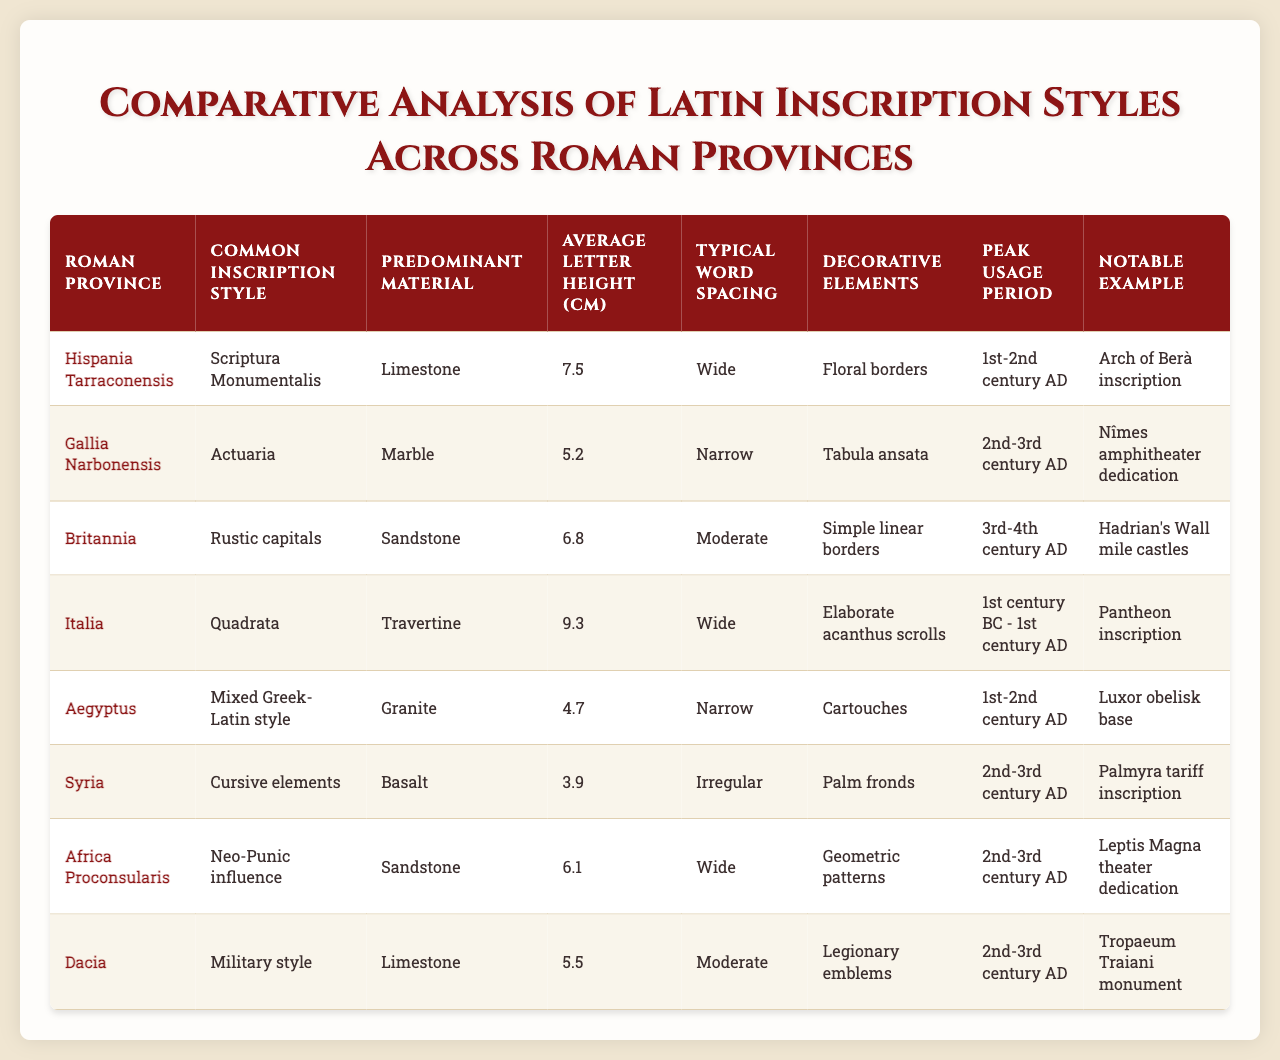What is the predominant material used for inscriptions in Hispania Tarraconensis? The table shows that the predominant material for inscriptions in Hispania Tarraconensis is Limestone.
Answer: Limestone Which Roman province has the widest average letter height? By comparing the average letter heights in the table, Italia has the widest average letter height at 9.3 cm.
Answer: 9.3 cm Is "Syria" associated with Cursive elements as the common inscription style? According to the table, "Syria" does indeed have Cursive elements as its common inscription style.
Answer: Yes Which inscription style is most commonly associated with Britannia? The table indicates that Britannia commonly uses Rustic capitals as the inscription style.
Answer: Rustic capitals What is the average letter height of inscriptions in Aegyptus? The table lists the average letter height for Aegyptus as 4.7 cm.
Answer: 4.7 cm How does the average letter height in Dacia compare to that in Gallia Narbonensis? The average letter height in Dacia is 5.5 cm, while in Gallia Narbonensis it is 5.2 cm, making Dacia's average letter height higher by 0.3 cm.
Answer: 0.3 cm higher Which province features geometric patterns as decorative elements and during which peak usage period? The table shows that Africa Proconsularis features geometric patterns as decorative elements during the 2nd-3rd century AD.
Answer: 2nd-3rd century AD Is the notable example of the inscription style in Hispania Tarraconensis the Arch of Berà inscription? Yes, the table confirms that the notable example for Hispania Tarraconensis is the Arch of Berà inscription.
Answer: Yes What is the sum of the average letter heights for inscriptions in Italia and Britannia? The average letter height for Italia is 9.3 cm and for Britannia is 6.8 cm. Adding these gives 9.3 + 6.8 = 16.1 cm.
Answer: 16.1 cm How many provinces listed have a peak usage period in the 2nd-3rd century AD? The table shows that there are four provinces (Gallia Narbonensis, Syria, Africa Proconsularis, and Dacia) with a peak usage period in the 2nd-3rd century AD.
Answer: 4 provinces 